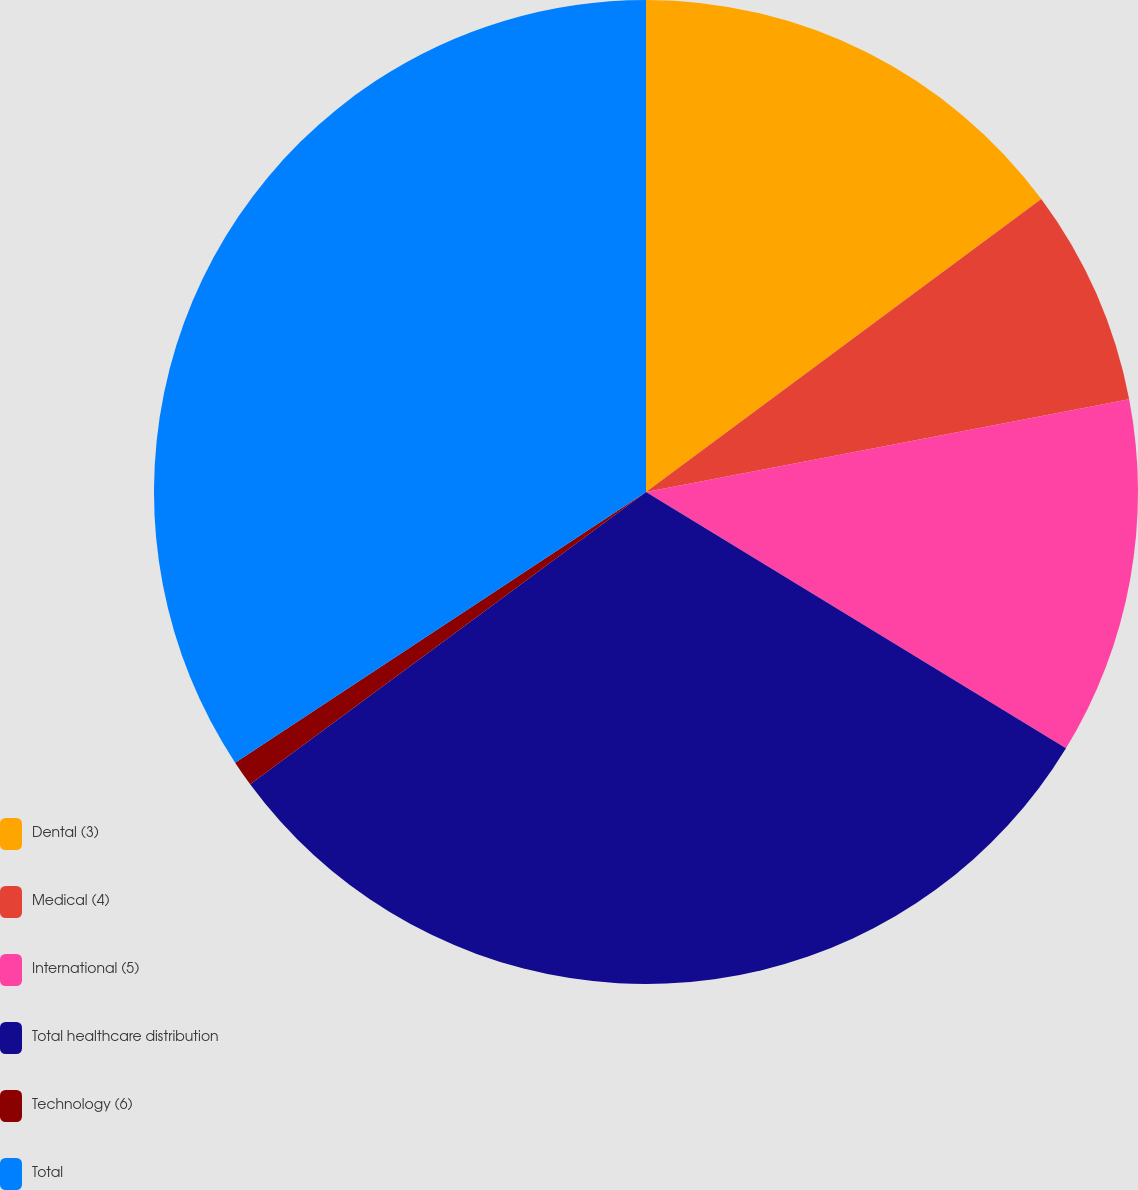<chart> <loc_0><loc_0><loc_500><loc_500><pie_chart><fcel>Dental (3)<fcel>Medical (4)<fcel>International (5)<fcel>Total healthcare distribution<fcel>Technology (6)<fcel>Total<nl><fcel>14.85%<fcel>7.13%<fcel>11.74%<fcel>31.16%<fcel>0.85%<fcel>34.27%<nl></chart> 